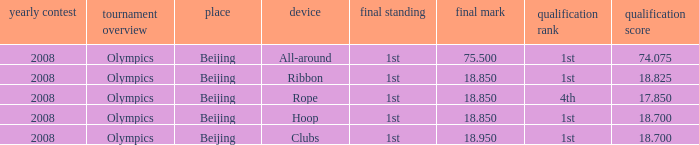What was her lowest final score with a qualifying score of 74.075? 75.5. 